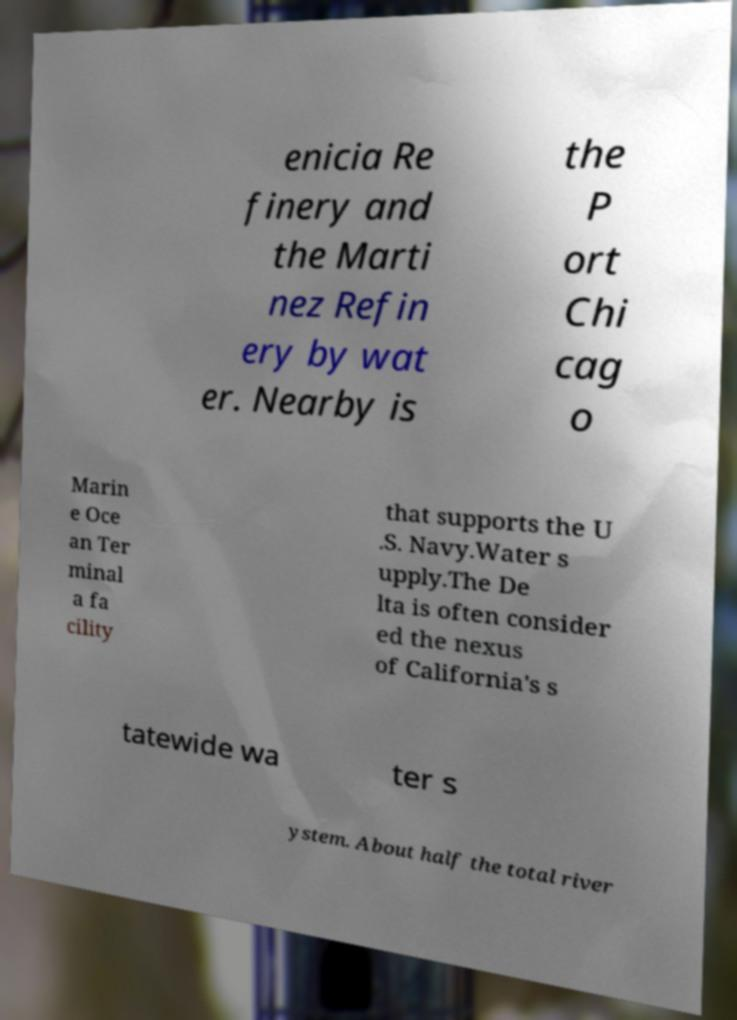Could you extract and type out the text from this image? enicia Re finery and the Marti nez Refin ery by wat er. Nearby is the P ort Chi cag o Marin e Oce an Ter minal a fa cility that supports the U .S. Navy.Water s upply.The De lta is often consider ed the nexus of California's s tatewide wa ter s ystem. About half the total river 